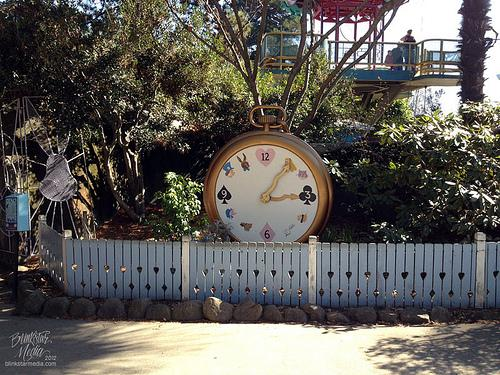Describe any relationships between the clock and nearby objects in the image. The clock is near small trees, a group of trees outside the fence, and has a large decorative clock by the fence. It is also potentially related to the gigantic pocket watch model mentioned in the descriptions. Count the number of fences described in the image captions and provide a brief description of each. There are four fences: a small white picket fence, a pale gray fence, a white fence, and a front white fence. The white picket fence has heart shapes cut into it. Analyze the sentiment or mood of the image based on the provided details. The image seems whimsical and lighthearted, featuring a large cartoonish clock with colorful details, heart shapes, and a small white picket fence. Compute the total number of trees present in the image based on the descriptions provided. There are two groups of trees mentioned in the descriptions, one consisting of small trees near the clock, and another group of trees outside the fence. Provide a brief description of the interaction between the fence and the surrounding environment. The fence interacts with its surroundings by having small holes cut in it and being lined by small rocks. There are trees outside it, and a statue beside it. Identify the largest object in the image and describe its appearance. A large cartoonish clock with a pink heart under the 12, a pink diamond under the 6, and squiggly golden arms. What is the quality of the image concerning the details provided about the shadows? The image is likely to have decent quality as there are shadows on the pavement, providing depth and realism to the scene. What time is shown on the clock and what is unique about its hands? The clock says 305, with the hour hand and minute hand being squiggly golden arms. Describe any shapes, symbols, or unique features associated with the clock in the image. The clock has a pink heart under the 12, a pink diamond under the 6, squiggly golden arms, and says 305. There is also a heart shape on top of the pocket watch. 